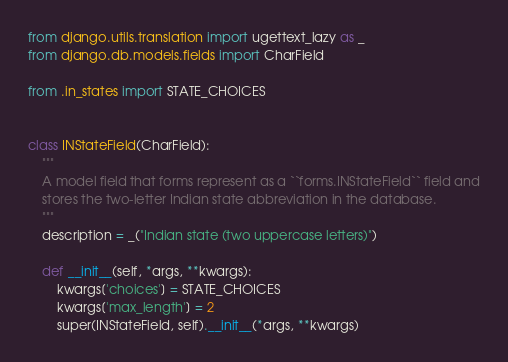<code> <loc_0><loc_0><loc_500><loc_500><_Python_>from django.utils.translation import ugettext_lazy as _
from django.db.models.fields import CharField

from .in_states import STATE_CHOICES


class INStateField(CharField):
    """
    A model field that forms represent as a ``forms.INStateField`` field and
    stores the two-letter Indian state abbreviation in the database.
    """
    description = _("Indian state (two uppercase letters)")

    def __init__(self, *args, **kwargs):
        kwargs['choices'] = STATE_CHOICES
        kwargs['max_length'] = 2
        super(INStateField, self).__init__(*args, **kwargs)
</code> 